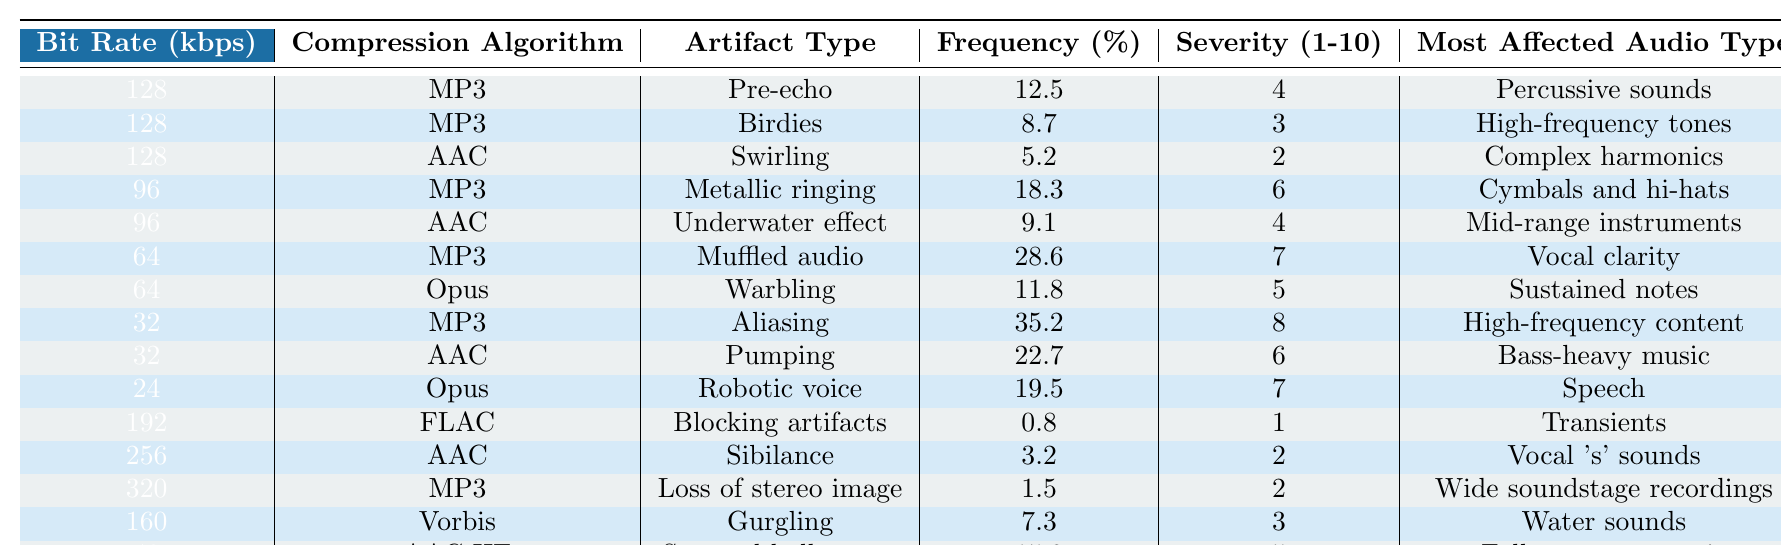What is the frequency of occurrence of "Muffled audio" for MP3 at 64 kbps? The table lists the frequency of occurrences for each artifact type at various bit rates. For the MP3 format at 64 kbps, the "Muffled audio" has a frequency of occurrence of 28.6%.
Answer: 28.6% Which artifact type has the highest frequency of occurrence at 32 kbps? At 32 kbps, the table shows two artifact types: "Aliasing" at 35.2% and "Pumping" at 22.7%. The highest frequency of occurrence is for "Aliasing".
Answer: Aliasing Is "Blocking artifacts" present in any audio encoder bitrate below 192 kbps? The table indicates that "Blocking artifacts" occurs only at 192 kbps under the FLAC compression algorithm and not at lower bit rates (such as 128, 96, 64, etc.). Therefore, it is not present below this bit rate.
Answer: No What is the average severity rating of artifacts for the AAC algorithm across all bit rates listed? The severity ratings for AAC artifacts are 2 (Swirling at 128 kbps), 4 (Underwater effect at 96 kbps), 6 (Pumping at 32 kbps), and 2 (Sibilance at 256 kbps). The sum of these ratings is 2 + 4 + 6 + 2 = 14, and there are 4 entries, so the average is 14/4 = 3.5.
Answer: 3.5 How does the frequency of occurrence of "Aliasing" compare to "Pre-echo" in terms of percentage? The table shows that "Aliasing" occurs at 35.2% at 32 kbps while "Pre-echo" occurs at 12.5% at 128 kbps. The difference is calculated as 35.2% - 12.5% = 22.7%, which indicates that "Aliasing" occurs significantly more frequently.
Answer: 22.7% Which audio type is most affected by "Robotic voice" and what is its severity rating? The table lists "Robotic voice" associated with the Opus algorithm at 24 kbps, affecting "Speech" and has a severity rating of 7.
Answer: Speech, severity 7 What is the total frequency of occurrence for artifacts specifically for MP3 compressed audio files? The frequencies for MP3 are: 12.5% (Pre-echo), 8.7% (Birdies), 18.3% (Metallic ringing), 28.6% (Muffled audio), 35.2% (Aliasing), and 1.5% (Loss of stereo image). Summing these gives 12.5 + 8.7 + 18.3 + 28.6 + 35.2 + 1.5 = 105.8%.
Answer: 105.8% Which artifact type has the lowest severity rating and what is its corresponding frequency? The table indicates that "Blocking artifacts" has the lowest severity rating of 1 and a corresponding frequency of 0.8%.
Answer: 0.8%, severity 1 What is the relationship between bit rate and the frequency of artifacts across the different formats shown in the table? Observing the data, as the bit rate decreases, the frequency of artifacts generally increases for the formats listed, suggesting that lower bit rates tend to produce more noticeable artifacts. This trend reflects the trade-off between bit rate and audio quality.
Answer: Lower bit rates lead to higher artifact frequencies 